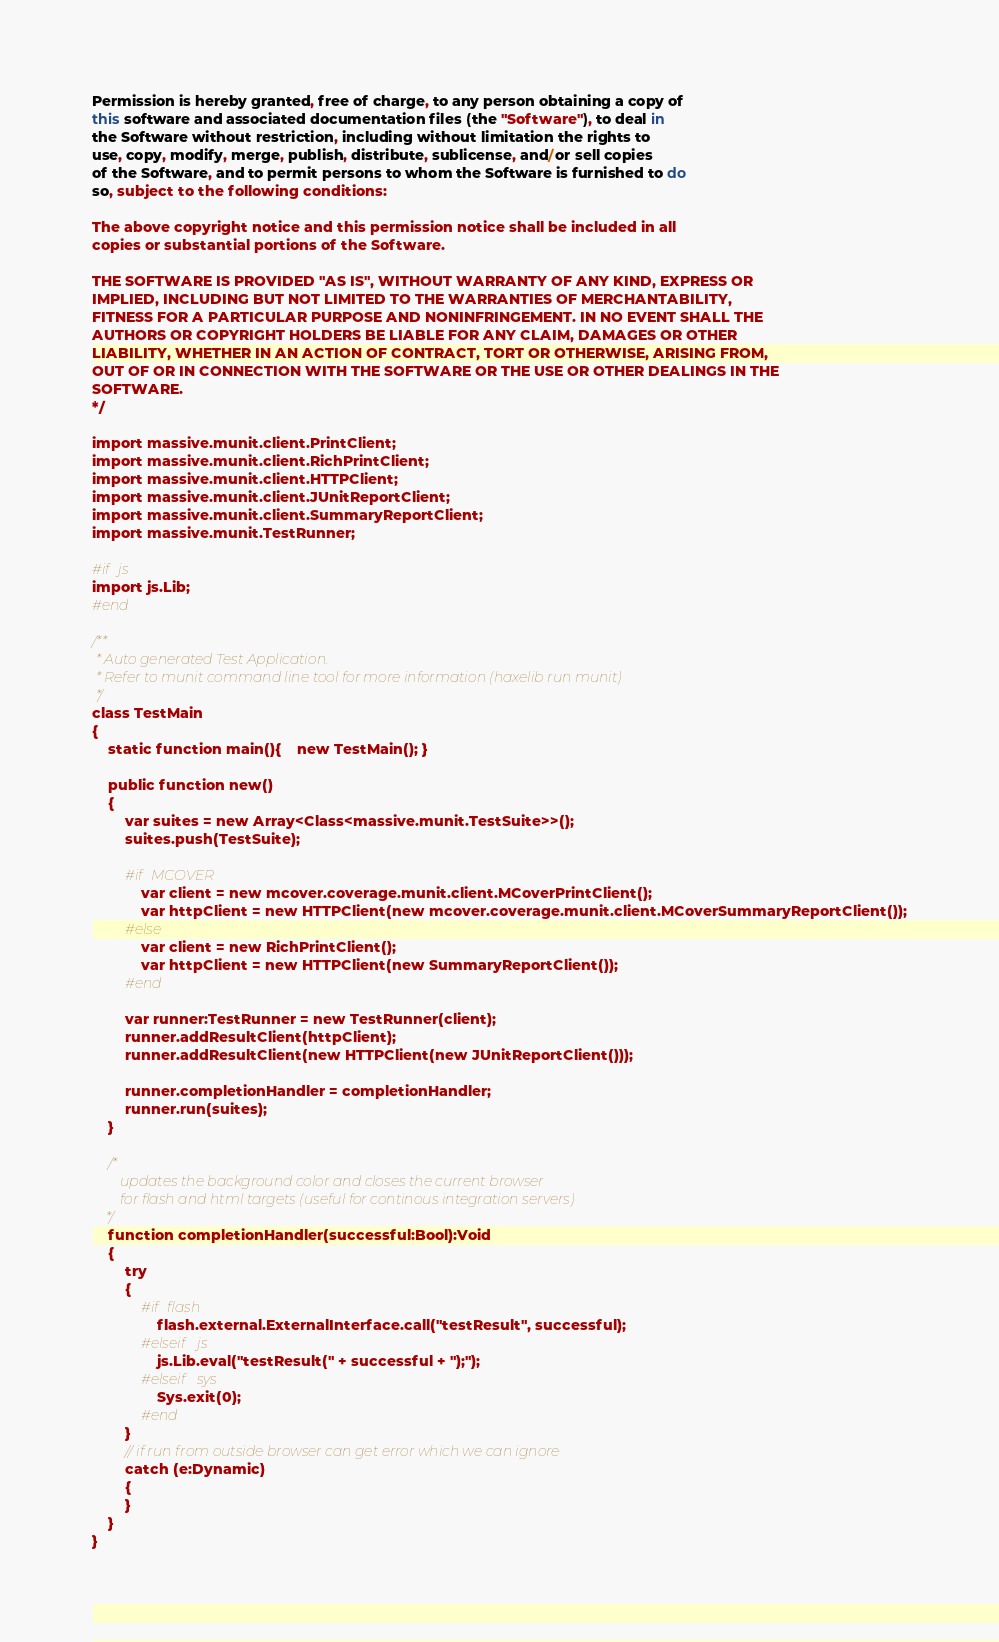Convert code to text. <code><loc_0><loc_0><loc_500><loc_500><_Haxe_>Permission is hereby granted, free of charge, to any person obtaining a copy of
this software and associated documentation files (the "Software"), to deal in
the Software without restriction, including without limitation the rights to
use, copy, modify, merge, publish, distribute, sublicense, and/or sell copies
of the Software, and to permit persons to whom the Software is furnished to do
so, subject to the following conditions:

The above copyright notice and this permission notice shall be included in all
copies or substantial portions of the Software.

THE SOFTWARE IS PROVIDED "AS IS", WITHOUT WARRANTY OF ANY KIND, EXPRESS OR
IMPLIED, INCLUDING BUT NOT LIMITED TO THE WARRANTIES OF MERCHANTABILITY,
FITNESS FOR A PARTICULAR PURPOSE AND NONINFRINGEMENT. IN NO EVENT SHALL THE
AUTHORS OR COPYRIGHT HOLDERS BE LIABLE FOR ANY CLAIM, DAMAGES OR OTHER
LIABILITY, WHETHER IN AN ACTION OF CONTRACT, TORT OR OTHERWISE, ARISING FROM,
OUT OF OR IN CONNECTION WITH THE SOFTWARE OR THE USE OR OTHER DEALINGS IN THE
SOFTWARE.
*/

import massive.munit.client.PrintClient;
import massive.munit.client.RichPrintClient;
import massive.munit.client.HTTPClient;
import massive.munit.client.JUnitReportClient;
import massive.munit.client.SummaryReportClient;
import massive.munit.TestRunner;

#if js
import js.Lib;
#end

/**
 * Auto generated Test Application.
 * Refer to munit command line tool for more information (haxelib run munit)
 */
class TestMain
{
    static function main(){	new TestMain(); }

    public function new()
    {
        var suites = new Array<Class<massive.munit.TestSuite>>();
        suites.push(TestSuite);

        #if MCOVER
            var client = new mcover.coverage.munit.client.MCoverPrintClient();
            var httpClient = new HTTPClient(new mcover.coverage.munit.client.MCoverSummaryReportClient());
        #else
            var client = new RichPrintClient();
            var httpClient = new HTTPClient(new SummaryReportClient());
        #end

        var runner:TestRunner = new TestRunner(client);
        runner.addResultClient(httpClient);
        runner.addResultClient(new HTTPClient(new JUnitReportClient()));

        runner.completionHandler = completionHandler;
        runner.run(suites);
    }

    /*
        updates the background color and closes the current browser
        for flash and html targets (useful for continous integration servers)
    */
    function completionHandler(successful:Bool):Void
    {
        try
        {
            #if flash
                flash.external.ExternalInterface.call("testResult", successful);
            #elseif js
                js.Lib.eval("testResult(" + successful + ");");
            #elseif sys
                Sys.exit(0);
            #end
        }
        // if run from outside browser can get error which we can ignore
        catch (e:Dynamic)
        {
        }
    }
}
</code> 